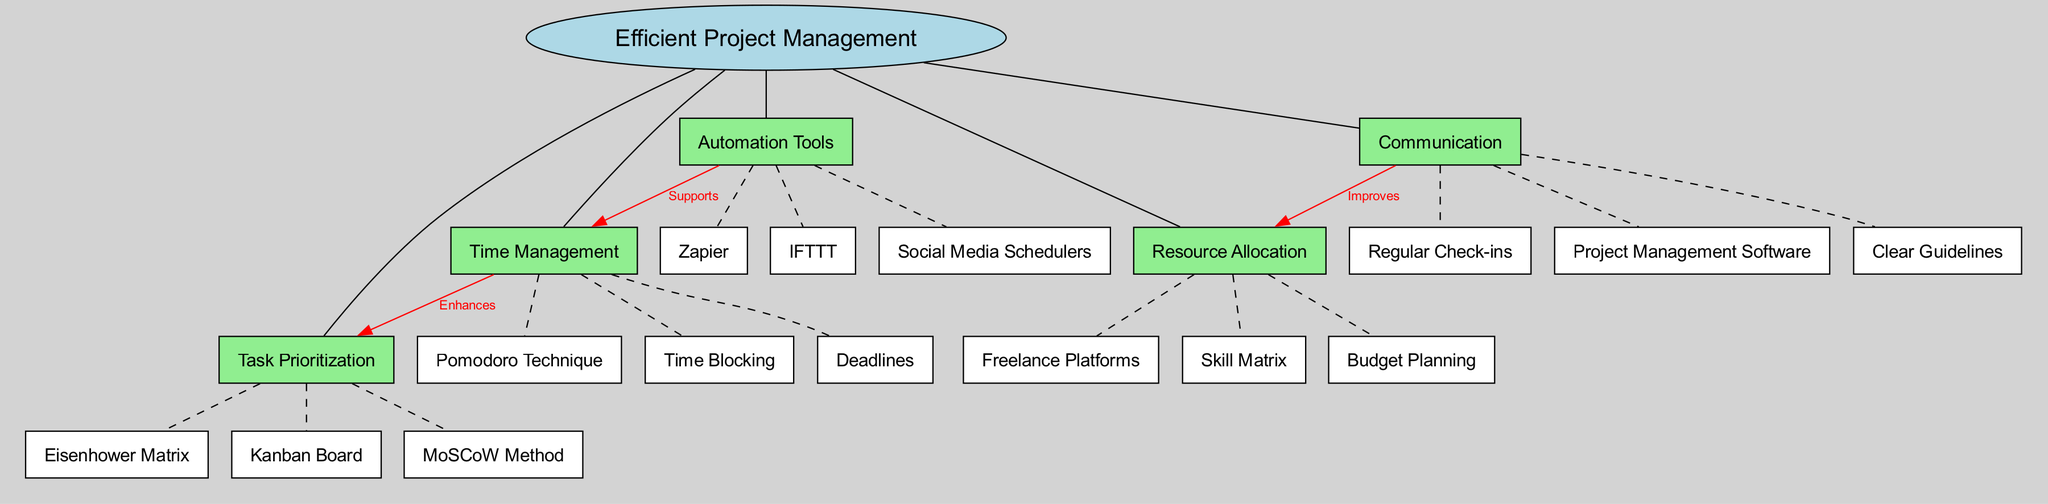What is the central concept of the diagram? The central concept is explicitly labeled within the diagram and is represented as the focus of the entire map. It is "Efficient Project Management."
Answer: Efficient Project Management How many main nodes are present in the diagram? The main nodes can be counted from the diagram's information provided. There are five main nodes related to efficient project management.
Answer: 5 What technique is categorized under Time Management? Looking under the Time Management node, multiple sub-nodes are listed. The Pomodoro Technique is explicitly mentioned as one of them.
Answer: Pomodoro Technique Which connection indicates an improvement in Resource Allocation? The diagram structure shows a directed edge from Communication to Resource Allocation labeled "Improves." This clearly indicates a relationship affecting those two nodes.
Answer: Improves How does Time Management relate to Task Prioritization? The connection is shown with a directed edge from Time Management to Task Prioritization labeled "Enhances," indicating that effective time management can improve how tasks are prioritized.
Answer: Enhances What method is listed under Task Prioritization? The Task Prioritization node has three sub-methods listed, one of which is the Kanban Board. The question looks for one of those methods.
Answer: Kanban Board What supports Time Management according to the diagram? The Automation Tools node is connected to Time Management with a label "Supports," indicating that automation tools play a role in enhancing time management strategies.
Answer: Supports How many tools are mentioned under Automation Tools? The number of distinct tools can be counted from the Automation Tools sub-node listing. Three are mentioned: Zapier, IFTTT, and Social Media Schedulers.
Answer: 3 What are the types of methods shown under Task Prioritization? Upon examining the Task Prioritization node, three methods are noted: Eisenhower Matrix, Kanban Board, and MoSCoW Method.
Answer: Eisenhower Matrix, Kanban Board, MoSCoW Method 